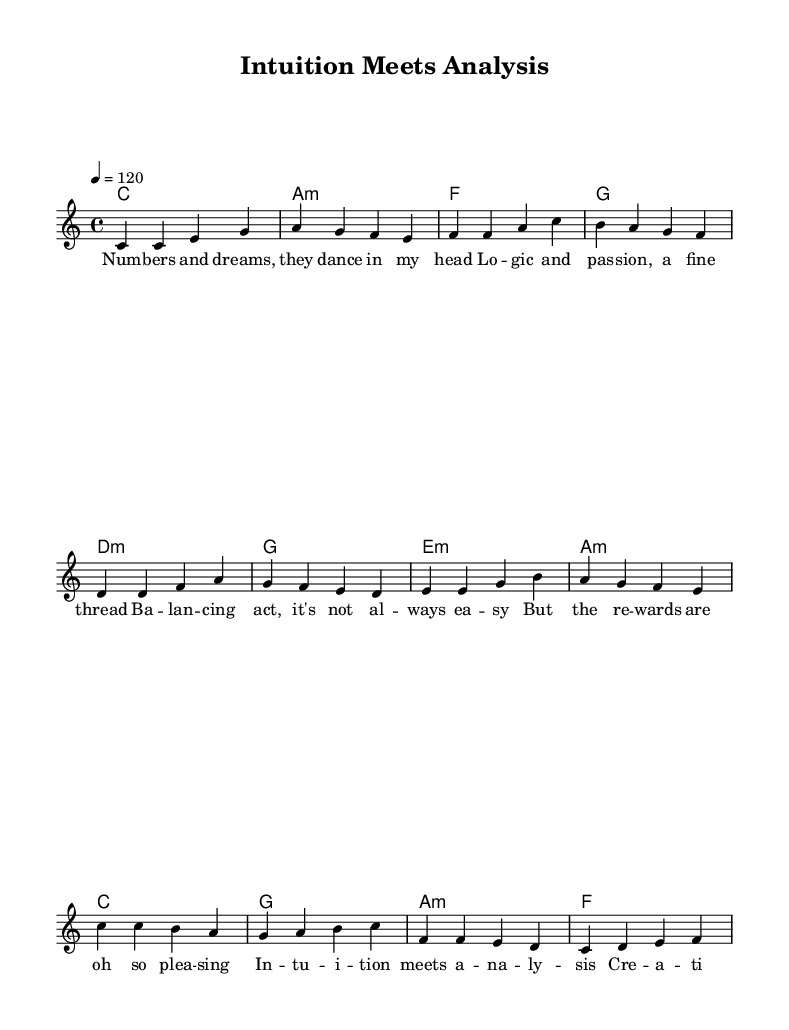What is the key signature of this music? The key signature is indicated in the global settings at the beginning of the sheet music, where it states "c \major", representing C major without sharps or flats.
Answer: C major What is the time signature of this music? The time signature is also found in the global settings, where it states "4/4", which means there are four beats per measure and the quarter note gets one beat.
Answer: 4/4 What is the tempo marking for this piece? The tempo is indicated in the global settings as "4 = 120", meaning there are four beats in a measure and the tempo is set to 120 beats per minute.
Answer: 120 How many sections are there in the song? Analyzing the structure, the song consists of three main parts: Verse, Pre-Chorus, and Chorus, as labeled in the melody sections.
Answer: Three What is the first lyric of the verse? The lyrics are written under the melody. The first line of the verse begins with "Num", so the first lyric is the first word provided in the lyrics section.
Answer: Num Based on the lyrics, what theme does the song explore? The lyrics mention "balancing act" and "creativity and logic", indicating the theme revolves around the relationship between creativity and analytical thinking in the workplace.
Answer: Balancing creativity and analysis What are the chord changes for the chorus? The chords for the chorus can be found under the Chorus section in the harmony. They are C major, G major, A minor, and F major, written sequentially.
Answer: C, G, A minor, F 